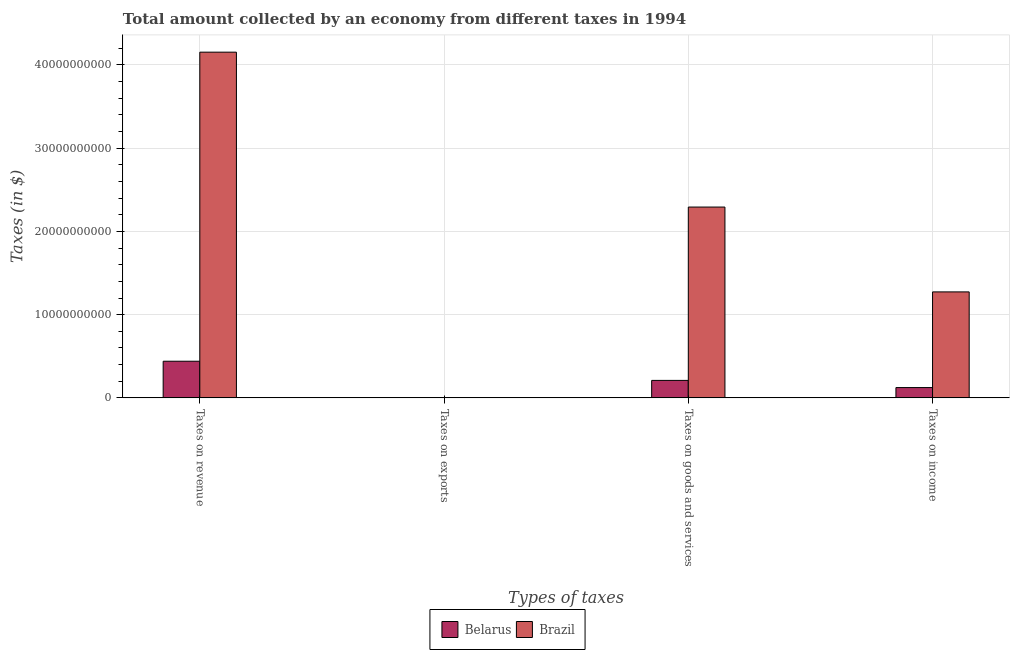How many groups of bars are there?
Your answer should be very brief. 4. Are the number of bars per tick equal to the number of legend labels?
Your answer should be compact. Yes. Are the number of bars on each tick of the X-axis equal?
Your response must be concise. Yes. How many bars are there on the 3rd tick from the left?
Give a very brief answer. 2. What is the label of the 1st group of bars from the left?
Your answer should be compact. Taxes on revenue. What is the amount collected as tax on revenue in Belarus?
Make the answer very short. 4.40e+09. Across all countries, what is the maximum amount collected as tax on revenue?
Your answer should be very brief. 4.15e+1. Across all countries, what is the minimum amount collected as tax on revenue?
Your response must be concise. 4.40e+09. In which country was the amount collected as tax on goods maximum?
Ensure brevity in your answer.  Brazil. In which country was the amount collected as tax on revenue minimum?
Your answer should be very brief. Belarus. What is the total amount collected as tax on income in the graph?
Offer a very short reply. 1.40e+1. What is the difference between the amount collected as tax on exports in Brazil and that in Belarus?
Make the answer very short. -3.70e+07. What is the difference between the amount collected as tax on income in Belarus and the amount collected as tax on revenue in Brazil?
Offer a very short reply. -4.03e+1. What is the average amount collected as tax on exports per country?
Your response must be concise. 1.89e+07. What is the difference between the amount collected as tax on exports and amount collected as tax on revenue in Belarus?
Provide a short and direct response. -4.37e+09. What is the ratio of the amount collected as tax on exports in Belarus to that in Brazil?
Provide a short and direct response. 93.5. Is the difference between the amount collected as tax on exports in Belarus and Brazil greater than the difference between the amount collected as tax on revenue in Belarus and Brazil?
Your answer should be very brief. Yes. What is the difference between the highest and the second highest amount collected as tax on goods?
Provide a succinct answer. 2.08e+1. What is the difference between the highest and the lowest amount collected as tax on goods?
Provide a succinct answer. 2.08e+1. Is it the case that in every country, the sum of the amount collected as tax on revenue and amount collected as tax on income is greater than the sum of amount collected as tax on exports and amount collected as tax on goods?
Your response must be concise. No. What does the 1st bar from the left in Taxes on exports represents?
Keep it short and to the point. Belarus. Is it the case that in every country, the sum of the amount collected as tax on revenue and amount collected as tax on exports is greater than the amount collected as tax on goods?
Your answer should be compact. Yes. How many bars are there?
Keep it short and to the point. 8. Are all the bars in the graph horizontal?
Your answer should be compact. No. How many countries are there in the graph?
Offer a terse response. 2. What is the difference between two consecutive major ticks on the Y-axis?
Keep it short and to the point. 1.00e+1. Are the values on the major ticks of Y-axis written in scientific E-notation?
Offer a very short reply. No. Does the graph contain any zero values?
Your answer should be compact. No. Where does the legend appear in the graph?
Make the answer very short. Bottom center. How many legend labels are there?
Your answer should be very brief. 2. How are the legend labels stacked?
Ensure brevity in your answer.  Horizontal. What is the title of the graph?
Give a very brief answer. Total amount collected by an economy from different taxes in 1994. Does "Tajikistan" appear as one of the legend labels in the graph?
Ensure brevity in your answer.  No. What is the label or title of the X-axis?
Your answer should be compact. Types of taxes. What is the label or title of the Y-axis?
Keep it short and to the point. Taxes (in $). What is the Taxes (in $) in Belarus in Taxes on revenue?
Keep it short and to the point. 4.40e+09. What is the Taxes (in $) of Brazil in Taxes on revenue?
Your answer should be compact. 4.15e+1. What is the Taxes (in $) of Belarus in Taxes on exports?
Your response must be concise. 3.74e+07. What is the Taxes (in $) in Brazil in Taxes on exports?
Your answer should be compact. 4.00e+05. What is the Taxes (in $) in Belarus in Taxes on goods and services?
Provide a succinct answer. 2.10e+09. What is the Taxes (in $) of Brazil in Taxes on goods and services?
Ensure brevity in your answer.  2.29e+1. What is the Taxes (in $) in Belarus in Taxes on income?
Offer a very short reply. 1.24e+09. What is the Taxes (in $) in Brazil in Taxes on income?
Your answer should be compact. 1.27e+1. Across all Types of taxes, what is the maximum Taxes (in $) of Belarus?
Keep it short and to the point. 4.40e+09. Across all Types of taxes, what is the maximum Taxes (in $) in Brazil?
Provide a short and direct response. 4.15e+1. Across all Types of taxes, what is the minimum Taxes (in $) of Belarus?
Make the answer very short. 3.74e+07. What is the total Taxes (in $) of Belarus in the graph?
Provide a short and direct response. 7.78e+09. What is the total Taxes (in $) in Brazil in the graph?
Offer a very short reply. 7.72e+1. What is the difference between the Taxes (in $) in Belarus in Taxes on revenue and that in Taxes on exports?
Your answer should be compact. 4.37e+09. What is the difference between the Taxes (in $) in Brazil in Taxes on revenue and that in Taxes on exports?
Your answer should be compact. 4.15e+1. What is the difference between the Taxes (in $) in Belarus in Taxes on revenue and that in Taxes on goods and services?
Provide a short and direct response. 2.30e+09. What is the difference between the Taxes (in $) of Brazil in Taxes on revenue and that in Taxes on goods and services?
Make the answer very short. 1.86e+1. What is the difference between the Taxes (in $) of Belarus in Taxes on revenue and that in Taxes on income?
Keep it short and to the point. 3.17e+09. What is the difference between the Taxes (in $) in Brazil in Taxes on revenue and that in Taxes on income?
Make the answer very short. 2.88e+1. What is the difference between the Taxes (in $) of Belarus in Taxes on exports and that in Taxes on goods and services?
Offer a terse response. -2.06e+09. What is the difference between the Taxes (in $) of Brazil in Taxes on exports and that in Taxes on goods and services?
Your answer should be very brief. -2.29e+1. What is the difference between the Taxes (in $) of Belarus in Taxes on exports and that in Taxes on income?
Give a very brief answer. -1.20e+09. What is the difference between the Taxes (in $) of Brazil in Taxes on exports and that in Taxes on income?
Provide a short and direct response. -1.27e+1. What is the difference between the Taxes (in $) in Belarus in Taxes on goods and services and that in Taxes on income?
Keep it short and to the point. 8.62e+08. What is the difference between the Taxes (in $) in Brazil in Taxes on goods and services and that in Taxes on income?
Offer a terse response. 1.02e+1. What is the difference between the Taxes (in $) in Belarus in Taxes on revenue and the Taxes (in $) in Brazil in Taxes on exports?
Provide a short and direct response. 4.40e+09. What is the difference between the Taxes (in $) in Belarus in Taxes on revenue and the Taxes (in $) in Brazil in Taxes on goods and services?
Give a very brief answer. -1.85e+1. What is the difference between the Taxes (in $) of Belarus in Taxes on revenue and the Taxes (in $) of Brazil in Taxes on income?
Provide a short and direct response. -8.33e+09. What is the difference between the Taxes (in $) in Belarus in Taxes on exports and the Taxes (in $) in Brazil in Taxes on goods and services?
Your answer should be very brief. -2.29e+1. What is the difference between the Taxes (in $) of Belarus in Taxes on exports and the Taxes (in $) of Brazil in Taxes on income?
Provide a succinct answer. -1.27e+1. What is the difference between the Taxes (in $) of Belarus in Taxes on goods and services and the Taxes (in $) of Brazil in Taxes on income?
Provide a succinct answer. -1.06e+1. What is the average Taxes (in $) of Belarus per Types of taxes?
Offer a very short reply. 1.94e+09. What is the average Taxes (in $) of Brazil per Types of taxes?
Ensure brevity in your answer.  1.93e+1. What is the difference between the Taxes (in $) of Belarus and Taxes (in $) of Brazil in Taxes on revenue?
Provide a succinct answer. -3.71e+1. What is the difference between the Taxes (in $) in Belarus and Taxes (in $) in Brazil in Taxes on exports?
Offer a very short reply. 3.70e+07. What is the difference between the Taxes (in $) in Belarus and Taxes (in $) in Brazil in Taxes on goods and services?
Your answer should be compact. -2.08e+1. What is the difference between the Taxes (in $) of Belarus and Taxes (in $) of Brazil in Taxes on income?
Provide a short and direct response. -1.15e+1. What is the ratio of the Taxes (in $) of Belarus in Taxes on revenue to that in Taxes on exports?
Ensure brevity in your answer.  117.75. What is the ratio of the Taxes (in $) in Brazil in Taxes on revenue to that in Taxes on exports?
Provide a succinct answer. 1.04e+05. What is the ratio of the Taxes (in $) of Belarus in Taxes on revenue to that in Taxes on goods and services?
Ensure brevity in your answer.  2.1. What is the ratio of the Taxes (in $) of Brazil in Taxes on revenue to that in Taxes on goods and services?
Your response must be concise. 1.81. What is the ratio of the Taxes (in $) of Belarus in Taxes on revenue to that in Taxes on income?
Keep it short and to the point. 3.56. What is the ratio of the Taxes (in $) in Brazil in Taxes on revenue to that in Taxes on income?
Your response must be concise. 3.26. What is the ratio of the Taxes (in $) of Belarus in Taxes on exports to that in Taxes on goods and services?
Your response must be concise. 0.02. What is the ratio of the Taxes (in $) of Belarus in Taxes on exports to that in Taxes on income?
Your answer should be compact. 0.03. What is the ratio of the Taxes (in $) in Brazil in Taxes on exports to that in Taxes on income?
Make the answer very short. 0. What is the ratio of the Taxes (in $) of Belarus in Taxes on goods and services to that in Taxes on income?
Your response must be concise. 1.7. What is the ratio of the Taxes (in $) in Brazil in Taxes on goods and services to that in Taxes on income?
Your answer should be compact. 1.8. What is the difference between the highest and the second highest Taxes (in $) in Belarus?
Ensure brevity in your answer.  2.30e+09. What is the difference between the highest and the second highest Taxes (in $) of Brazil?
Offer a very short reply. 1.86e+1. What is the difference between the highest and the lowest Taxes (in $) of Belarus?
Offer a very short reply. 4.37e+09. What is the difference between the highest and the lowest Taxes (in $) of Brazil?
Offer a very short reply. 4.15e+1. 